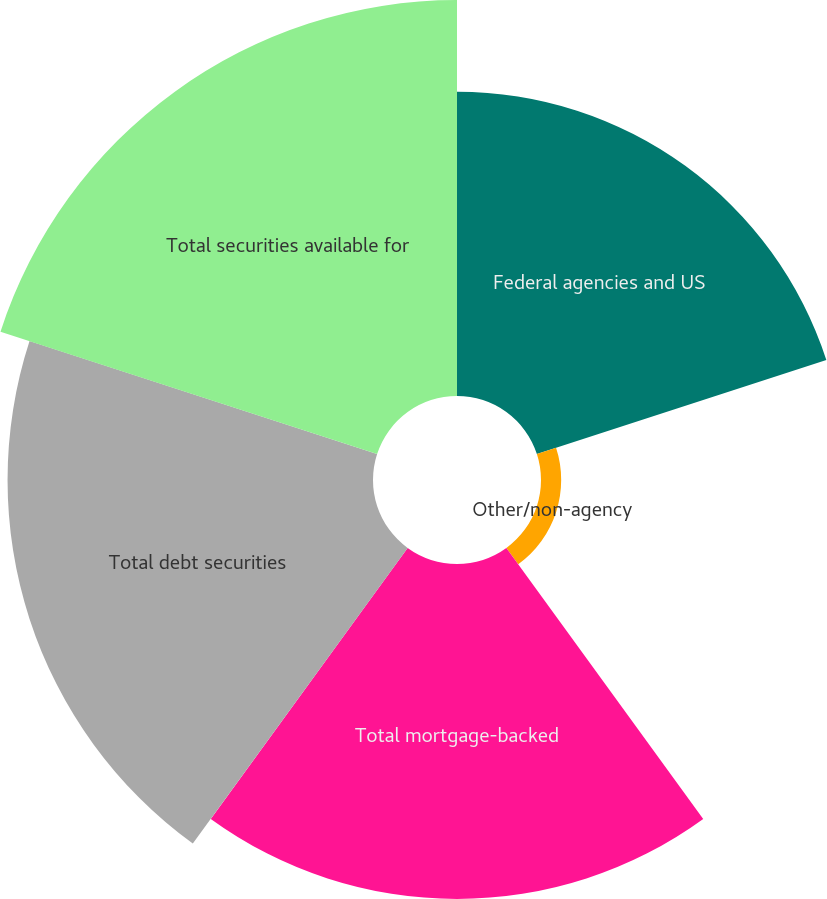Convert chart. <chart><loc_0><loc_0><loc_500><loc_500><pie_chart><fcel>Federal agencies and US<fcel>Other/non-agency<fcel>Total mortgage-backed<fcel>Total debt securities<fcel>Total securities available for<nl><fcel>21.42%<fcel>1.42%<fcel>23.57%<fcel>25.72%<fcel>27.87%<nl></chart> 